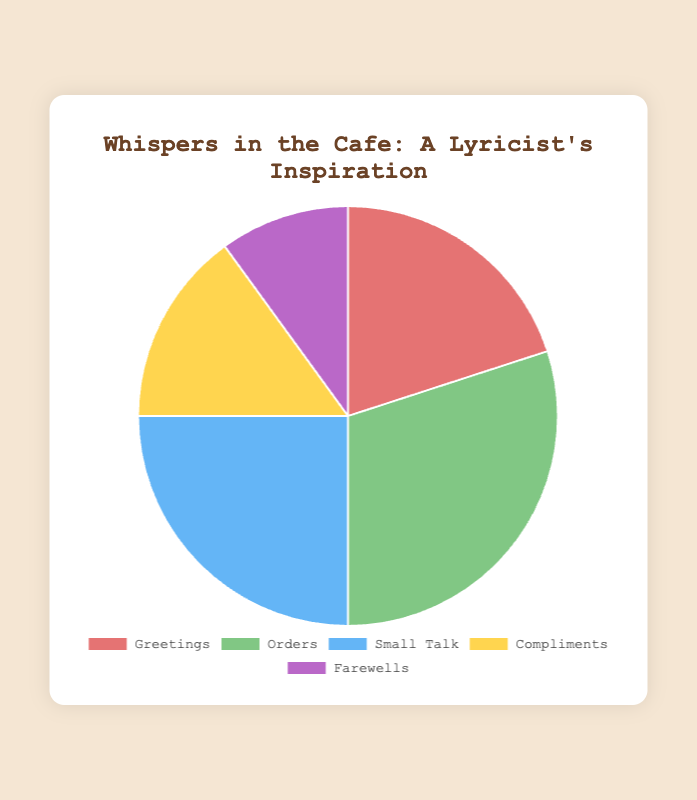Which category has the highest percentage of words used in cafe conversations? According to the pie chart, the Orders category has the largest segment.
Answer: Orders Which category has the lowest percentage of words used in cafe conversations? The smallest segment in the pie chart represents Farewells.
Answer: Farewells What is the combined percentage of words used for Greetings and Farewells? Add the percentages of Greetings (20%) and Farewells (10%): 20% + 10% = 30%
Answer: 30% How much greater is the percentage of words used for Small Talk compared to Compliments? Subtract the percentage of Compliments (15%) from the percentage of Small Talk (25%): 25% - 15% = 10%
Answer: 10% Which categories together make up half of the words used in conversations? Calculate the sum of Orders (30%) and Small Talk (25%), which is greater than 50%, so Orders (30%) and Greetings (20%) exactly make up 50%.
Answer: Orders and Greetings What is the difference in percentage between the highest and lowest categories? Subtract the percentage of Farewells (10%) from Orders (30%): 30% - 10% = 20%
Answer: 20% Is the percentage of Orders more than the sum of Compliments and Farewells? Yes, Orders (30%) is greater than the sum of Compliments (15%) and Farewells (10%): 15% + 10% = 25%, and 30% > 25%
Answer: Yes Which category has a percentage closest to the average percentage of all categories? Calculate the average percentage: (20% + 30% + 25% + 15% + 10%) / 5 = 20%, and the category closest to this is Greetings with 20%.
Answer: Greetings How do the colors used in the chart help in identifying different categories? Each category is visually distinguished by a unique color: red for Greetings, green for Orders, blue for Small Talk, yellow for Compliments, and purple for Farewells, making it easier to differentiate the segments.
Answer: Unique colors for each category What percentage of words are not used for Small Talk? Subtract the percentage of Small Talk (25%) from 100%: 100% - 25% = 75%
Answer: 75% 